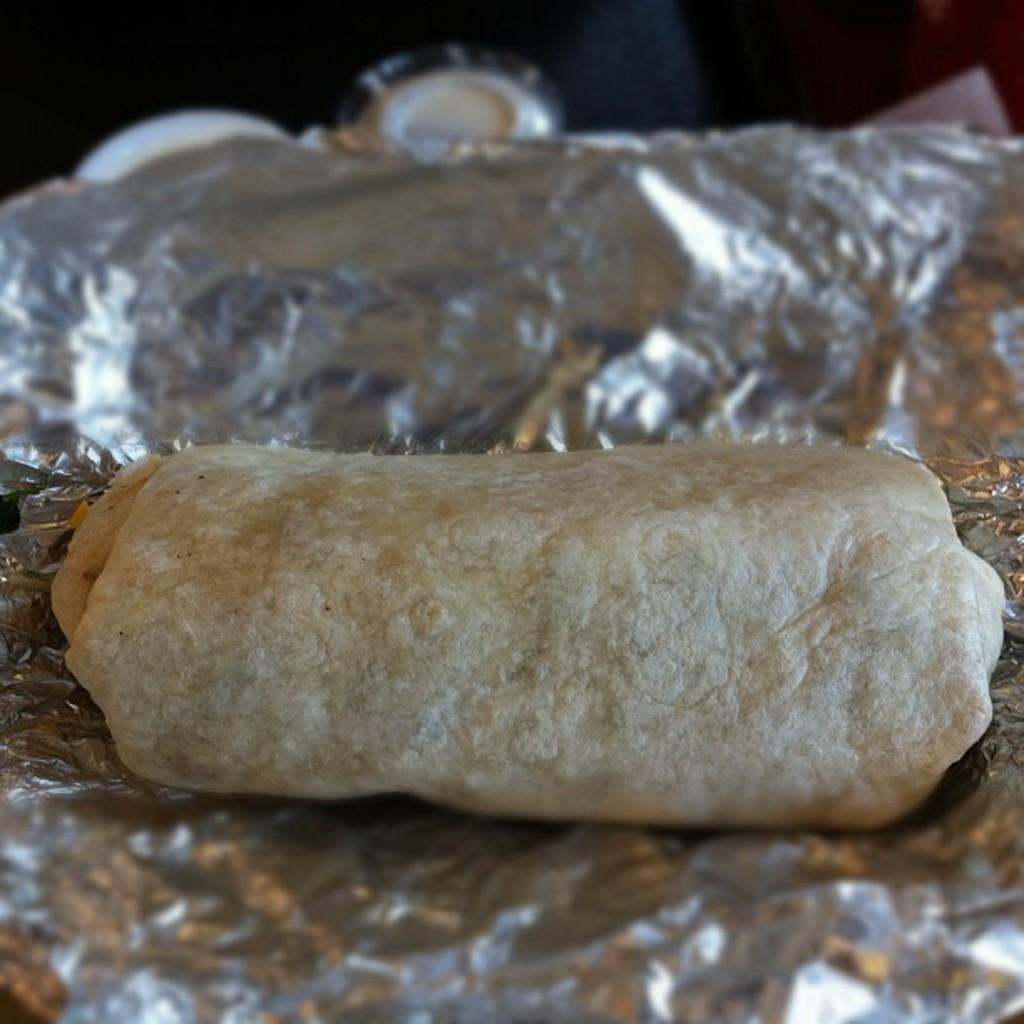What type of food item is wrapped in silver foil in the image? The specific type of food item cannot be determined from the image. Can you describe the appearance of the food item in the image? The food item is wrapped in silver foil, but its shape or size cannot be determined. What might be the purpose of wrapping the food item in silver foil? Wrapping the food item in silver foil could be for preservation, presentation, or convenience. What nation is represented by the banana in the image? There is no banana present in the image, and therefore no nation can be represented by it. 